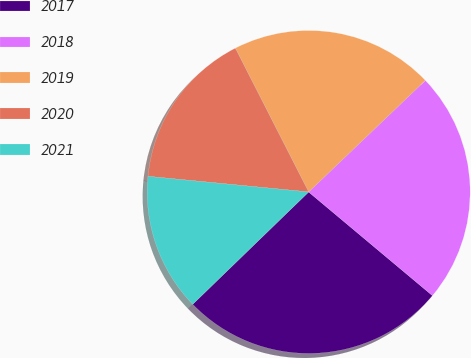Convert chart. <chart><loc_0><loc_0><loc_500><loc_500><pie_chart><fcel>2017<fcel>2018<fcel>2019<fcel>2020<fcel>2021<nl><fcel>26.66%<fcel>23.24%<fcel>20.36%<fcel>15.95%<fcel>13.79%<nl></chart> 